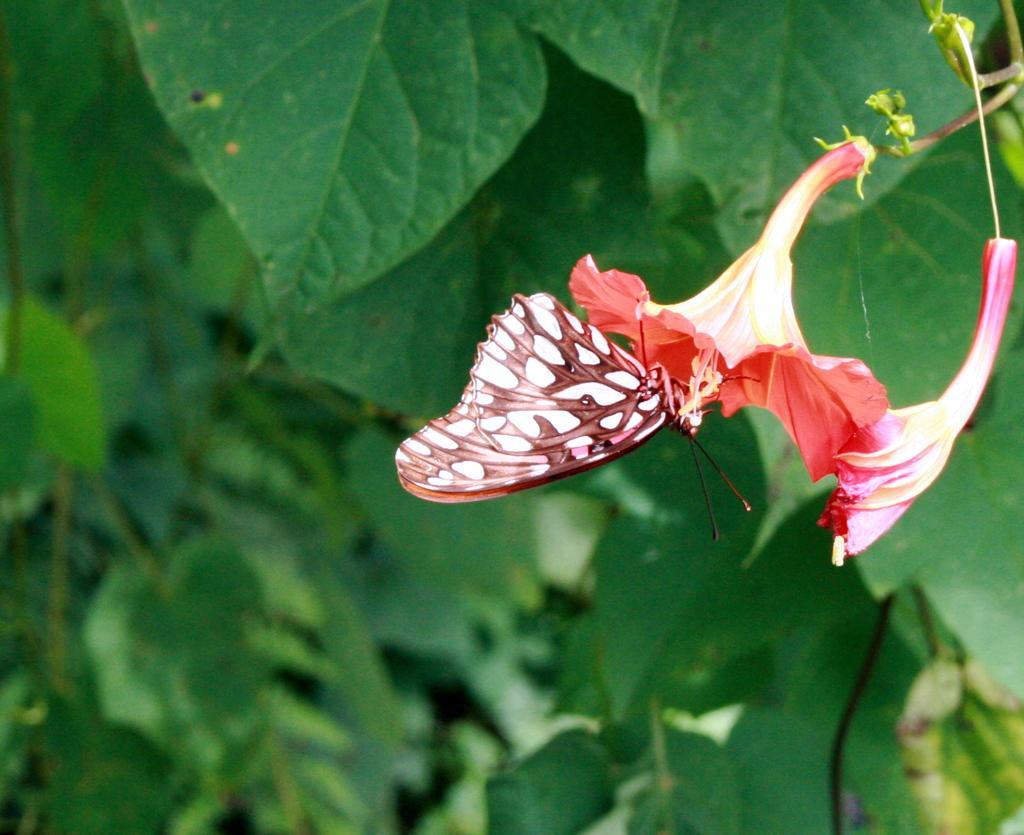Can you describe this image briefly? In this image there is a butterfly on the flower. In the background of the image there are leaves. 